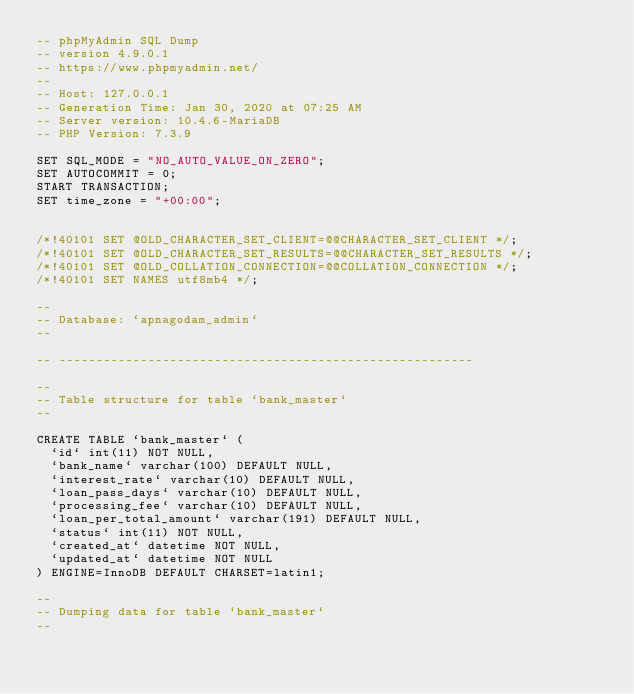<code> <loc_0><loc_0><loc_500><loc_500><_SQL_>-- phpMyAdmin SQL Dump
-- version 4.9.0.1
-- https://www.phpmyadmin.net/
--
-- Host: 127.0.0.1
-- Generation Time: Jan 30, 2020 at 07:25 AM
-- Server version: 10.4.6-MariaDB
-- PHP Version: 7.3.9

SET SQL_MODE = "NO_AUTO_VALUE_ON_ZERO";
SET AUTOCOMMIT = 0;
START TRANSACTION;
SET time_zone = "+00:00";


/*!40101 SET @OLD_CHARACTER_SET_CLIENT=@@CHARACTER_SET_CLIENT */;
/*!40101 SET @OLD_CHARACTER_SET_RESULTS=@@CHARACTER_SET_RESULTS */;
/*!40101 SET @OLD_COLLATION_CONNECTION=@@COLLATION_CONNECTION */;
/*!40101 SET NAMES utf8mb4 */;

--
-- Database: `apnagodam_admin`
--

-- --------------------------------------------------------

--
-- Table structure for table `bank_master`
--

CREATE TABLE `bank_master` (
  `id` int(11) NOT NULL,
  `bank_name` varchar(100) DEFAULT NULL,
  `interest_rate` varchar(10) DEFAULT NULL,
  `loan_pass_days` varchar(10) DEFAULT NULL,
  `processing_fee` varchar(10) DEFAULT NULL,
  `loan_per_total_amount` varchar(191) DEFAULT NULL,
  `status` int(11) NOT NULL,
  `created_at` datetime NOT NULL,
  `updated_at` datetime NOT NULL
) ENGINE=InnoDB DEFAULT CHARSET=latin1;

--
-- Dumping data for table `bank_master`
--
</code> 